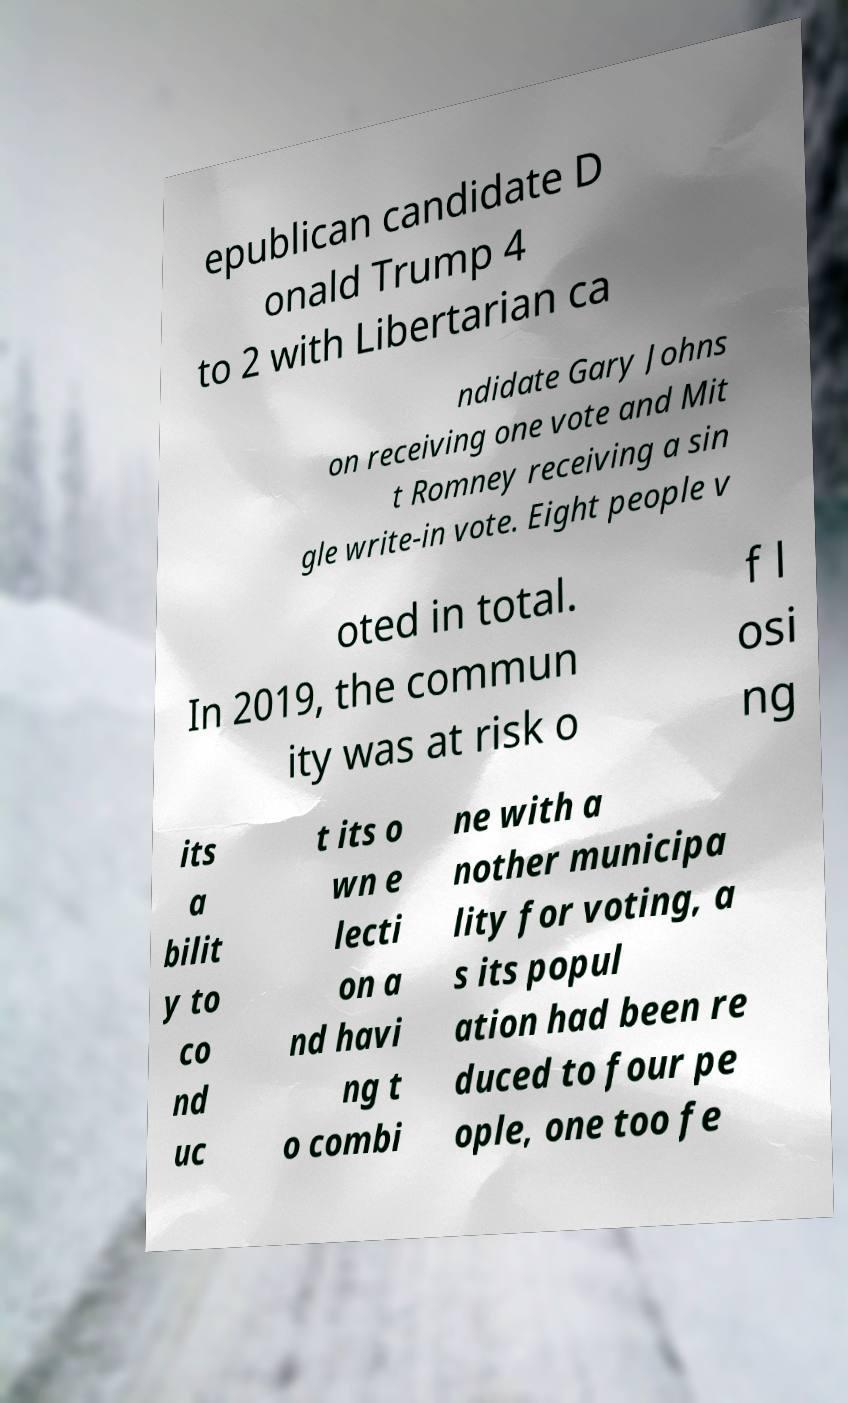Can you accurately transcribe the text from the provided image for me? epublican candidate D onald Trump 4 to 2 with Libertarian ca ndidate Gary Johns on receiving one vote and Mit t Romney receiving a sin gle write-in vote. Eight people v oted in total. In 2019, the commun ity was at risk o f l osi ng its a bilit y to co nd uc t its o wn e lecti on a nd havi ng t o combi ne with a nother municipa lity for voting, a s its popul ation had been re duced to four pe ople, one too fe 